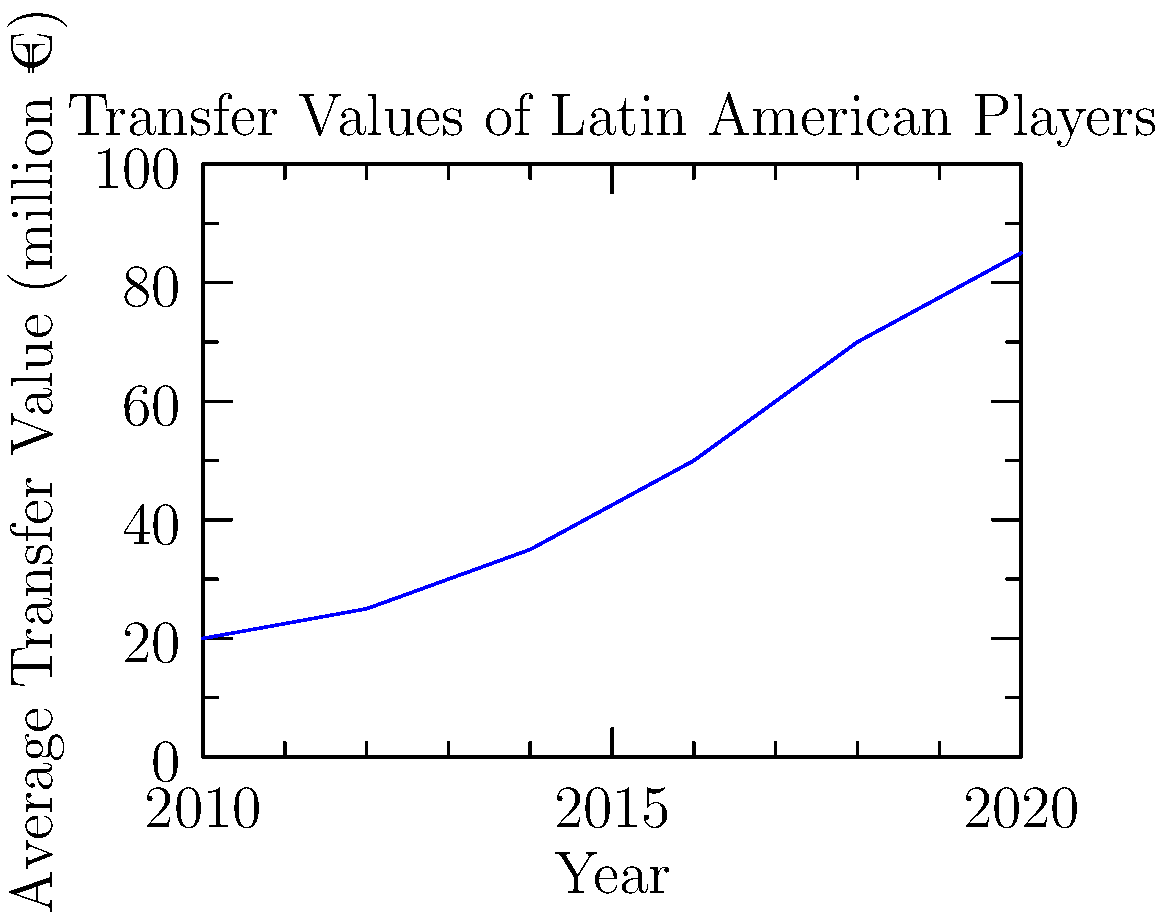Based on the line graph showing the average transfer values of Latin American players to European clubs from 2010 to 2020, what was the approximate percentage increase in transfer values between 2010 and 2020? To calculate the percentage increase in transfer values between 2010 and 2020:

1. Identify the values:
   - 2010 value: €20 million
   - 2020 value: €85 million

2. Calculate the difference:
   €85 million - €20 million = €65 million

3. Divide the difference by the initial value:
   €65 million ÷ €20 million = 3.25

4. Convert to percentage:
   3.25 × 100 = 325%

The transfer values increased by approximately 325% from 2010 to 2020.
Answer: 325% 